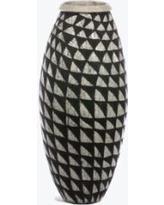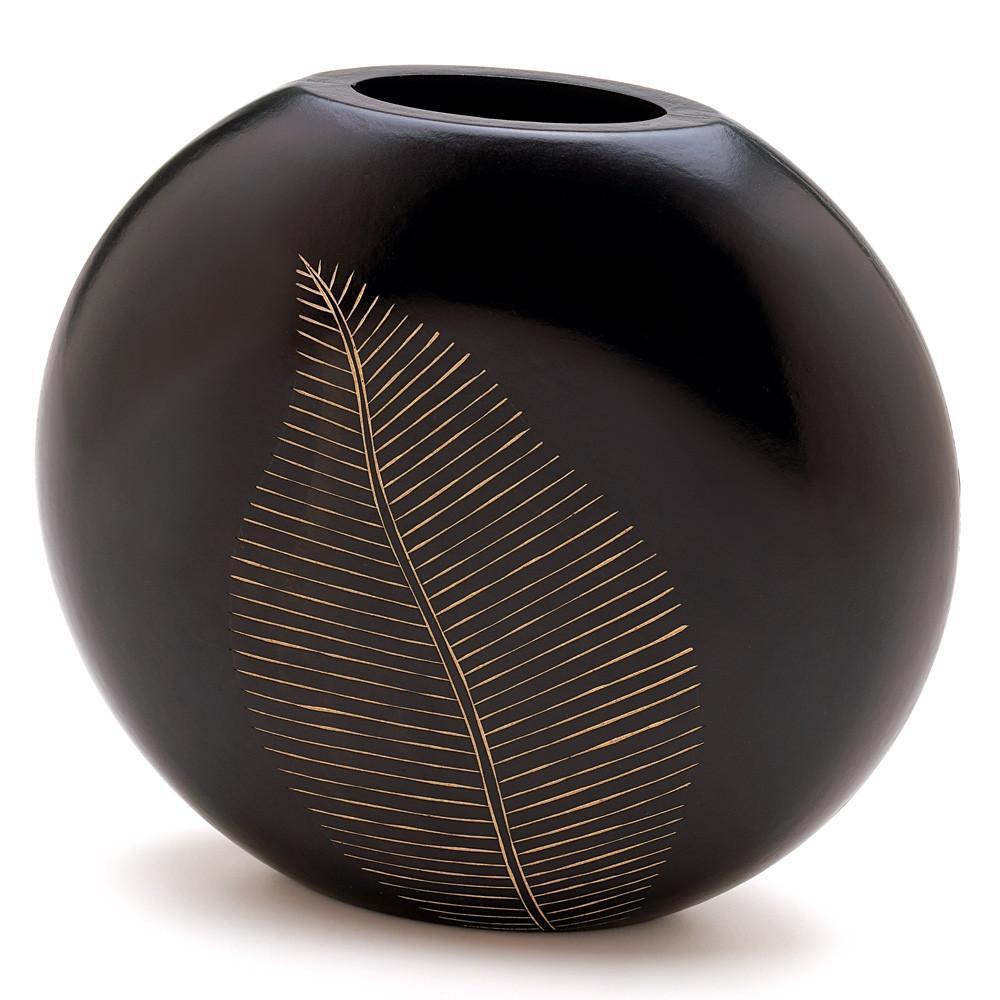The first image is the image on the left, the second image is the image on the right. Given the left and right images, does the statement "The left image contains a set of three vases with similar patterns but different shapes and heights." hold true? Answer yes or no. No. The first image is the image on the left, the second image is the image on the right. For the images displayed, is the sentence "there are three vases of varying sizes" factually correct? Answer yes or no. No. 